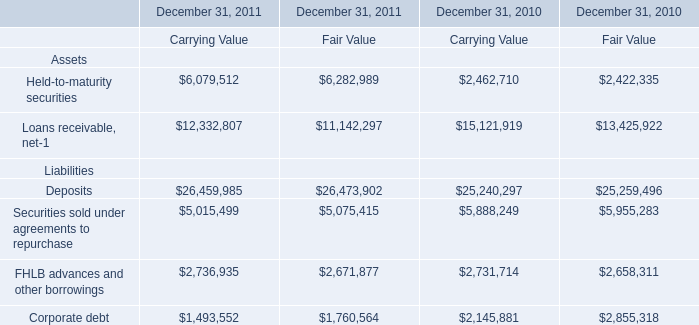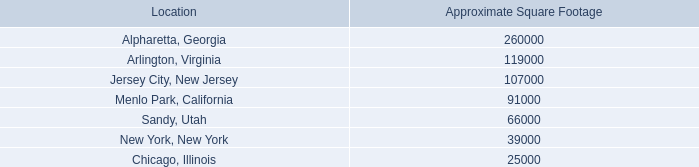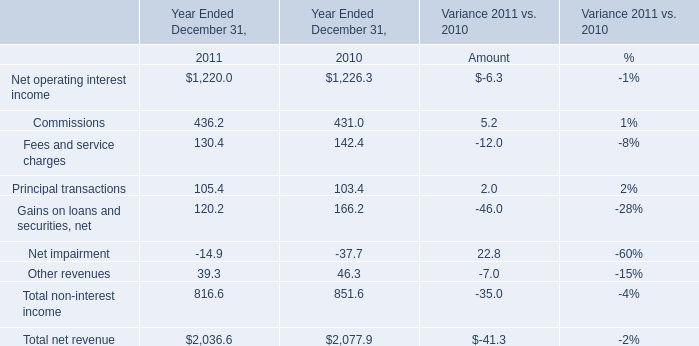What is the percentage of Net operating interest income in relation to the total in 2011? 
Computations: (1220 / 2036.6)
Answer: 0.59904. 